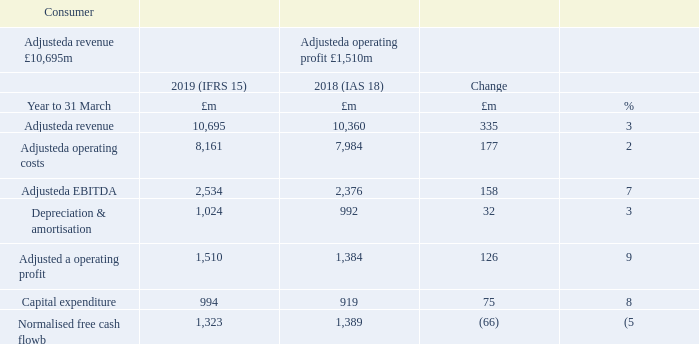We continue to experience challenging trends in both the high-end smartphone market and in the broadband market. However, with leading mobile and fixed networks, improving customer experience, three strong brands and further enhancements to BT Plus, with 5G coming imminently, we are well placed for the future.
Adjusteda revenue growth of 3% for the year was driven by the continued increase in handset costs for customers, growth in the SIMonly base across all brands and the impact of price increases, partially offset by solus voice price reductions.
Adjusteda EBITDA grew 7% for the year as the revenue growth was partially offset by increased trading costs.
Capital expenditure growth of 8% was driven by increased network spend as preparations were made for the EE 5G launch in 2019. Normalised free cash flowb was £1,323m, down 5% on last year as the increase in EBITDA was offset by the settlement at the start of the year of the Phones4U dispute relating to the retail trading agreement, and increased capital expenditure.
Mobile churnc was stable at 1.2% for the year, whilst fixed churnc was up from 1.3% to 1.4% reflecting the impact of price increases in the year.
a Adjusted measures exclude specific items, as explained in the Additional Information on page 185. b Free cash flow after net interest paid, before pension deficit payments (including the cash tax benefit of pension deficit payments) and specific items.
What was the Adjusted revenue change? 3%. What was the Adjusted EBITDA change? 7%. What was the reason for capital expenditure growth? Driven by increased network spend as preparations were made for the ee 5g launch in 2019. What was the average Adjusted EBITDA for 2018 and 2019?
Answer scale should be: million. (2,534 + 2,376) / 2
Answer: 2455. What  was the EBITDA margin in 2019? 2,534 / 10,695
Answer: 0.24. What is the average Adjusteda operating costs for 2018 and 2019?
Answer scale should be: million. (8,161 + 7,984) / 2
Answer: 8072.5. 